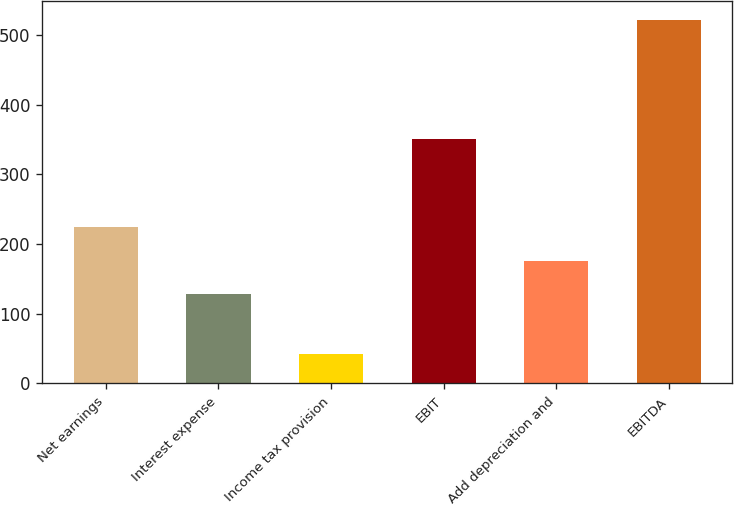<chart> <loc_0><loc_0><loc_500><loc_500><bar_chart><fcel>Net earnings<fcel>Interest expense<fcel>Income tax provision<fcel>EBIT<fcel>Add depreciation and<fcel>EBITDA<nl><fcel>224<fcel>128.1<fcel>42.4<fcel>350.4<fcel>176.05<fcel>521.9<nl></chart> 